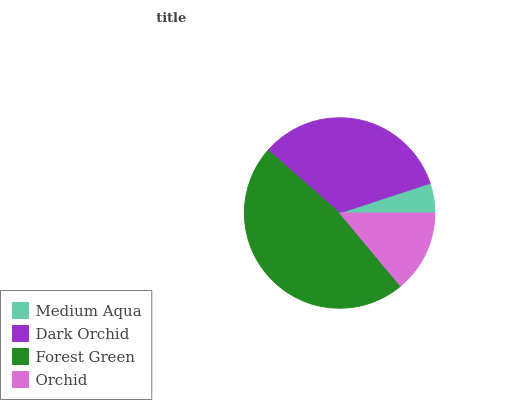Is Medium Aqua the minimum?
Answer yes or no. Yes. Is Forest Green the maximum?
Answer yes or no. Yes. Is Dark Orchid the minimum?
Answer yes or no. No. Is Dark Orchid the maximum?
Answer yes or no. No. Is Dark Orchid greater than Medium Aqua?
Answer yes or no. Yes. Is Medium Aqua less than Dark Orchid?
Answer yes or no. Yes. Is Medium Aqua greater than Dark Orchid?
Answer yes or no. No. Is Dark Orchid less than Medium Aqua?
Answer yes or no. No. Is Dark Orchid the high median?
Answer yes or no. Yes. Is Orchid the low median?
Answer yes or no. Yes. Is Orchid the high median?
Answer yes or no. No. Is Forest Green the low median?
Answer yes or no. No. 